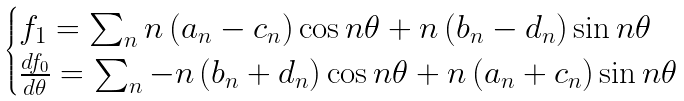Convert formula to latex. <formula><loc_0><loc_0><loc_500><loc_500>\begin{cases} f _ { 1 } = \sum _ { n } n \left ( a _ { n } - c _ { n } \right ) \cos n \theta + n \left ( b _ { n } - d _ { n } \right ) \sin n \theta \\ \frac { d f _ { 0 } } { d \theta } = \sum _ { n } - n \left ( b _ { n } + d _ { n } \right ) \cos n \theta + n \left ( a _ { n } + c _ { n } \right ) \sin n \theta \\ \end{cases}</formula> 